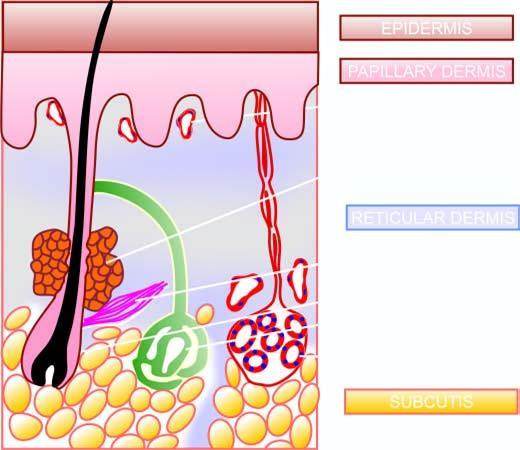where is main structures identified in?
Answer the question using a single word or phrase. A section of the normal skin 